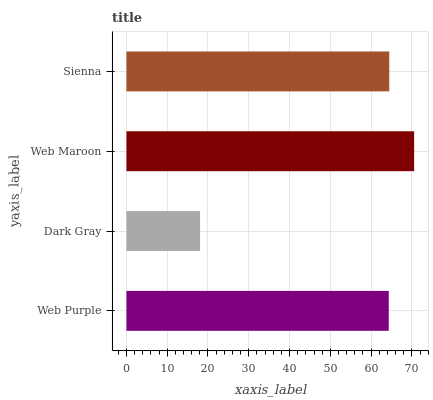Is Dark Gray the minimum?
Answer yes or no. Yes. Is Web Maroon the maximum?
Answer yes or no. Yes. Is Web Maroon the minimum?
Answer yes or no. No. Is Dark Gray the maximum?
Answer yes or no. No. Is Web Maroon greater than Dark Gray?
Answer yes or no. Yes. Is Dark Gray less than Web Maroon?
Answer yes or no. Yes. Is Dark Gray greater than Web Maroon?
Answer yes or no. No. Is Web Maroon less than Dark Gray?
Answer yes or no. No. Is Sienna the high median?
Answer yes or no. Yes. Is Web Purple the low median?
Answer yes or no. Yes. Is Web Purple the high median?
Answer yes or no. No. Is Sienna the low median?
Answer yes or no. No. 